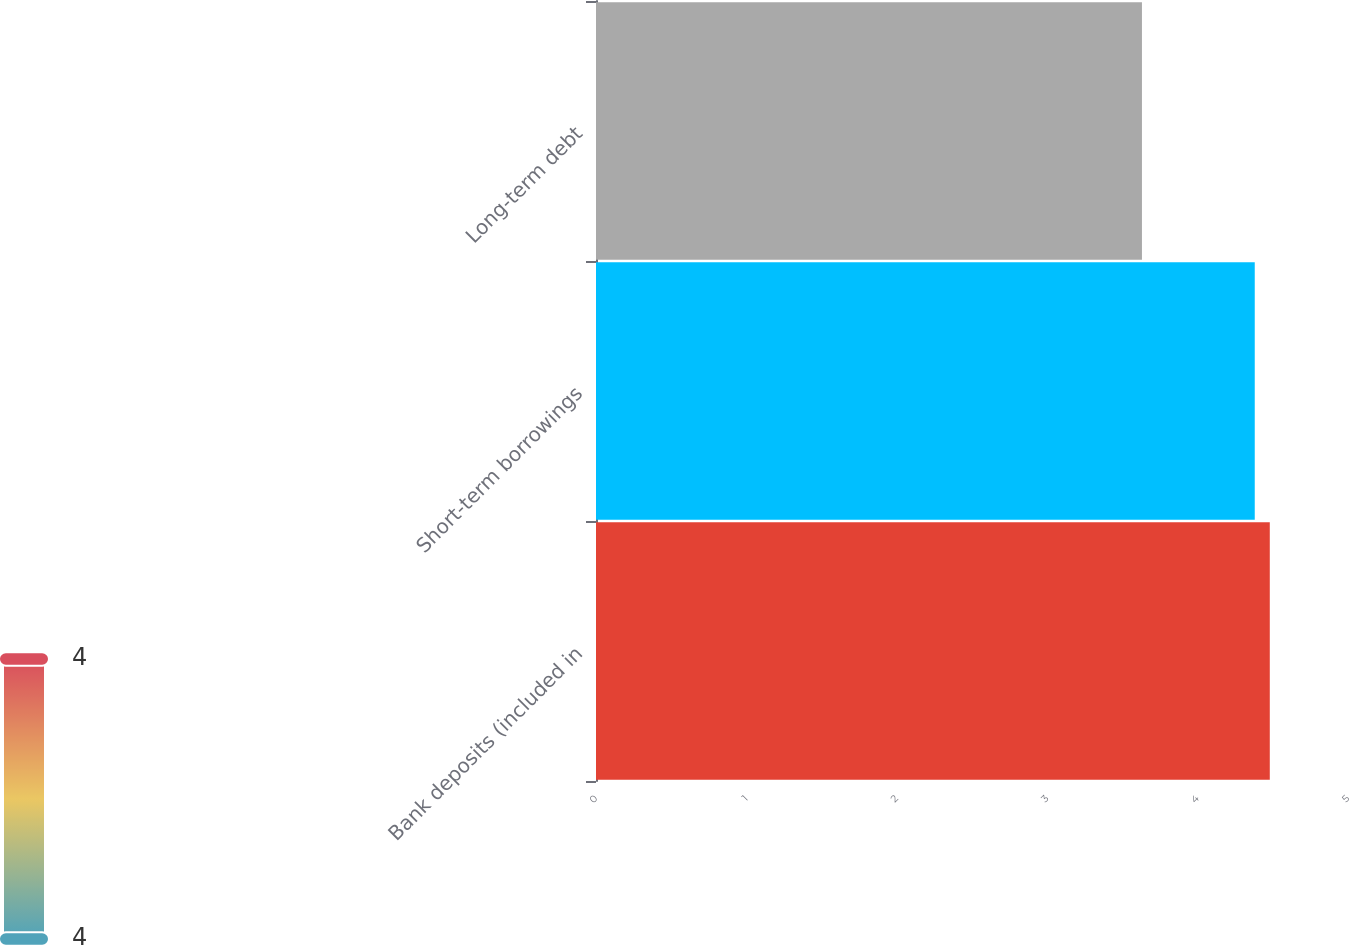Convert chart. <chart><loc_0><loc_0><loc_500><loc_500><bar_chart><fcel>Bank deposits (included in<fcel>Short-term borrowings<fcel>Long-term debt<nl><fcel>4.48<fcel>4.38<fcel>3.63<nl></chart> 